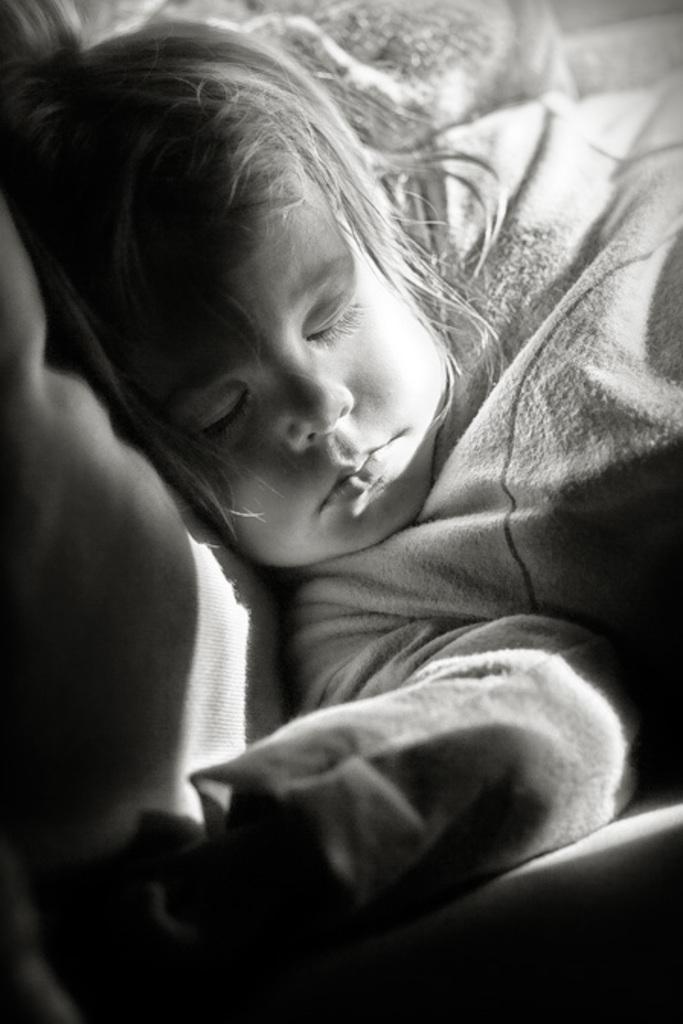In one or two sentences, can you explain what this image depicts? This is a black and white picture. There is a child sleeping. 